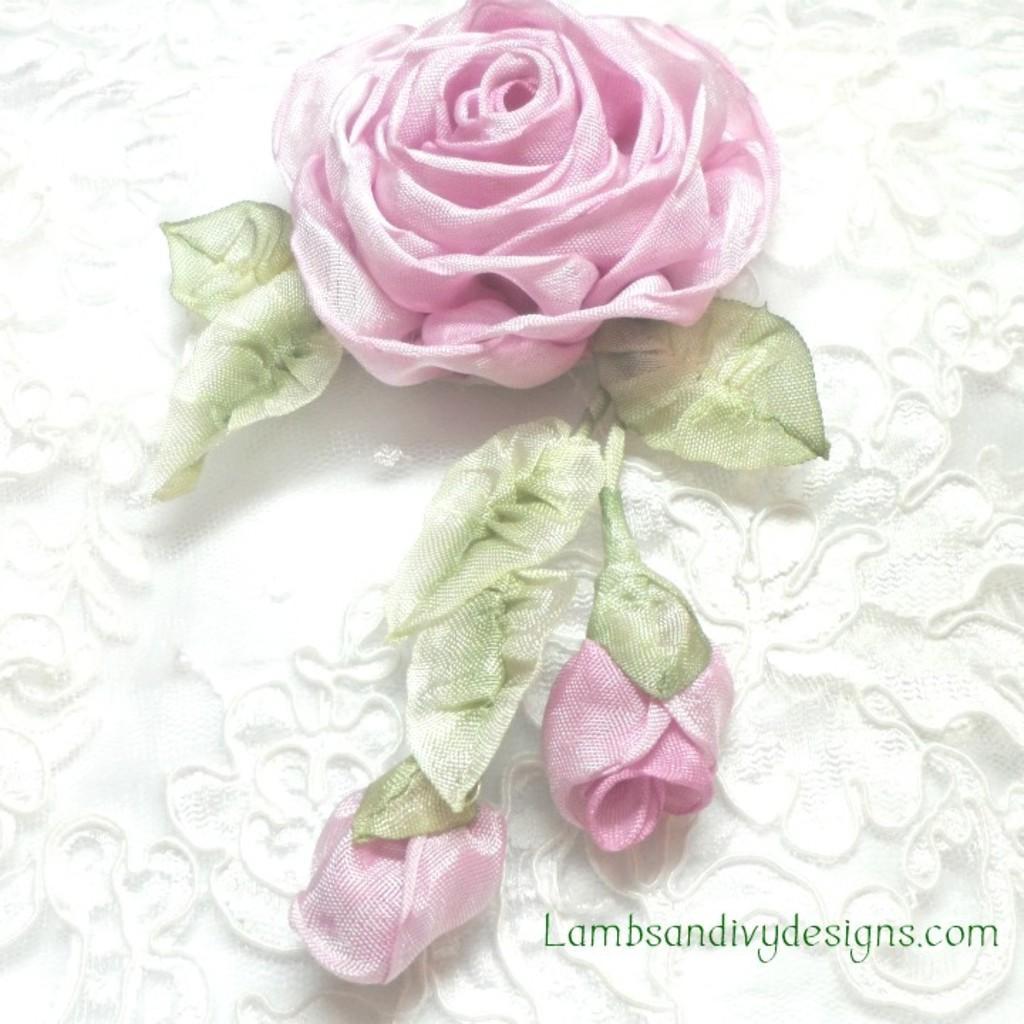Could you give a brief overview of what you see in this image? In the center of the image we can see a flower, leaves and a bud are present. 